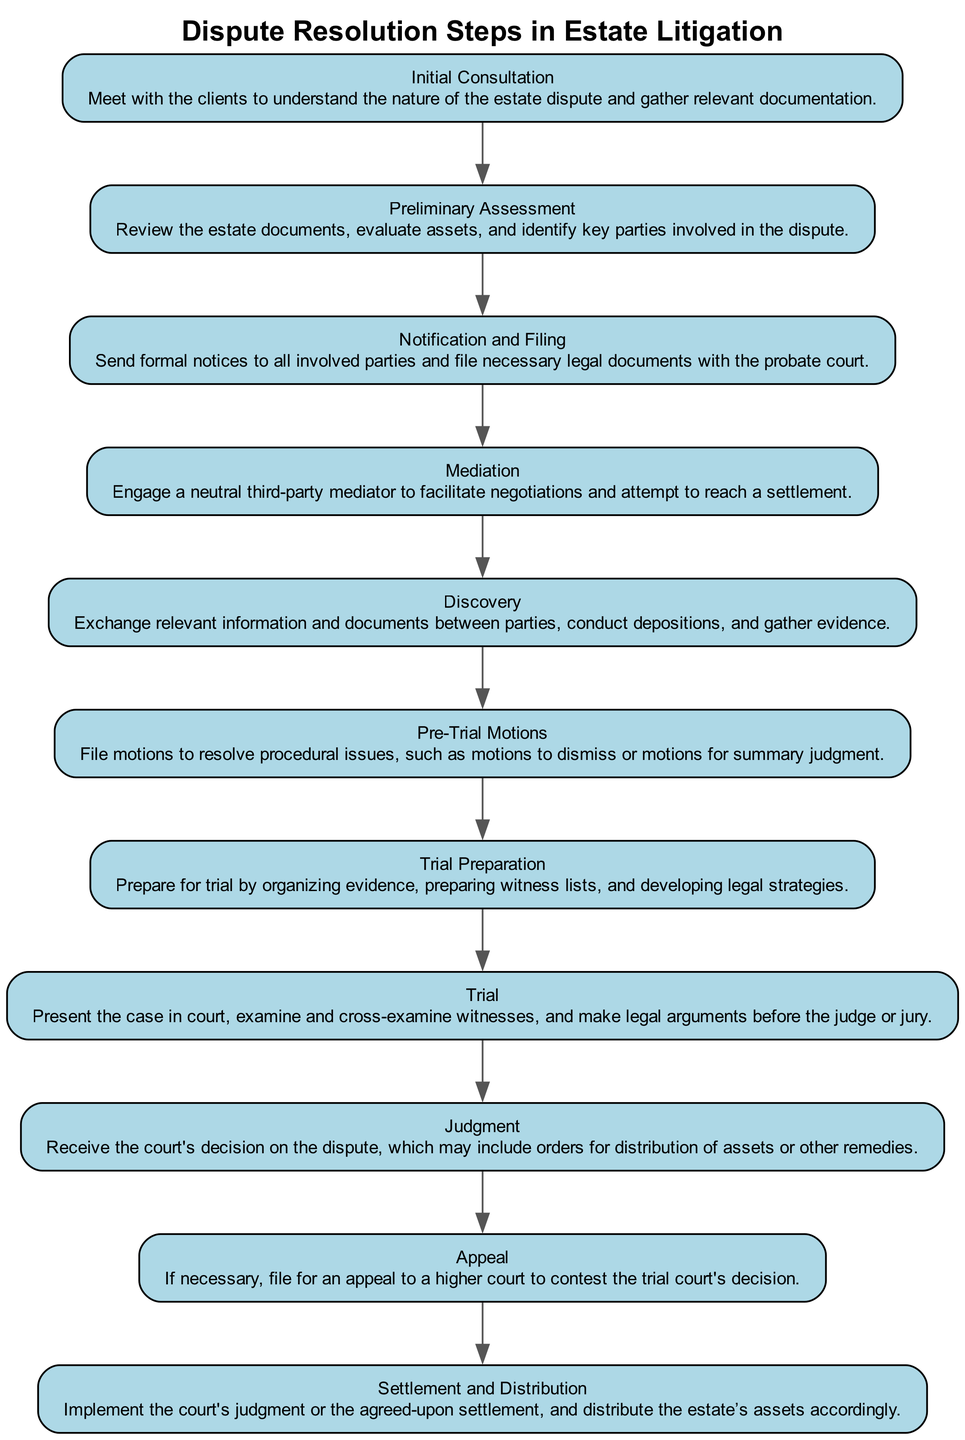What is the first step in the dispute resolution process? The diagram starts with "Initial Consultation" as the first step in the dispute resolution process.
Answer: Initial Consultation How many steps are there in total? The diagram outlines a total of 11 steps in the dispute resolution process, as each step is represented as a node.
Answer: 11 What follows after "Mediation"? After "Mediation," the next step in the diagram is "Discovery," indicating the flow of steps in the dispute resolution process.
Answer: Discovery Which step involves filing necessary legal documents? The step associated with filing necessary legal documents is "Notification and Filing." This can be found directly after "Preliminary Assessment."
Answer: Notification and Filing Which two steps precede "Trial"? The two steps that precede "Trial" are "Trial Preparation" and "Pre-Trial Motions," which are shown sequentially before reaching the trial stage.
Answer: Trial Preparation, Pre-Trial Motions What action is taken if a party disagrees with the court's decision? If a party disagrees with the court's decision, the appropriate action is to file for an "Appeal," as indicated in the flow after the "Judgment" step.
Answer: Appeal How does the "Judgment" step relate to "Settlement and Distribution"? The "Judgment" step leads directly to the "Settlement and Distribution" step in the diagram, showing a sequence where the court's decision results in asset distribution or settlement.
Answer: Directly leads to Which step includes engaging a neutral third-party? "Mediation" is the step that includes engaging a neutral third-party mediator to facilitate negotiations, as specified in the details of the diagram.
Answer: Mediation What is the purpose of the "Discovery" step? The purpose of the "Discovery" step is to exchange relevant information and documents between parties, which is clearly outlined in the step's details.
Answer: Exchange relevant information and documents 